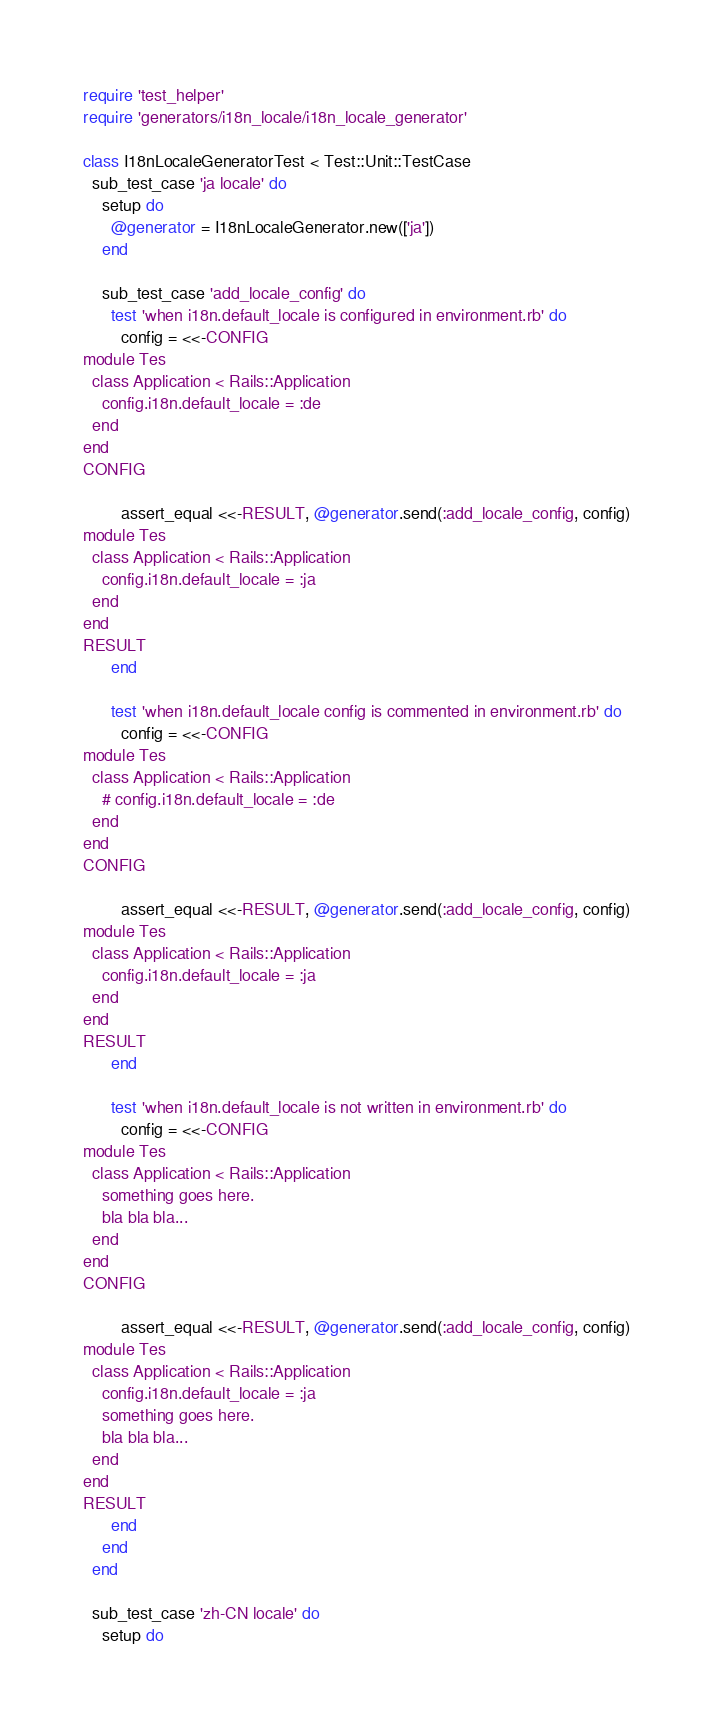Convert code to text. <code><loc_0><loc_0><loc_500><loc_500><_Ruby_>require 'test_helper'
require 'generators/i18n_locale/i18n_locale_generator'

class I18nLocaleGeneratorTest < Test::Unit::TestCase
  sub_test_case 'ja locale' do
    setup do
      @generator = I18nLocaleGenerator.new(['ja'])
    end

    sub_test_case 'add_locale_config' do
      test 'when i18n.default_locale is configured in environment.rb' do
        config = <<-CONFIG
module Tes
  class Application < Rails::Application
    config.i18n.default_locale = :de
  end
end
CONFIG

        assert_equal <<-RESULT, @generator.send(:add_locale_config, config)
module Tes
  class Application < Rails::Application
    config.i18n.default_locale = :ja
  end
end
RESULT
      end

      test 'when i18n.default_locale config is commented in environment.rb' do
        config = <<-CONFIG
module Tes
  class Application < Rails::Application
    # config.i18n.default_locale = :de
  end
end
CONFIG

        assert_equal <<-RESULT, @generator.send(:add_locale_config, config)
module Tes
  class Application < Rails::Application
    config.i18n.default_locale = :ja
  end
end
RESULT
      end

      test 'when i18n.default_locale is not written in environment.rb' do
        config = <<-CONFIG
module Tes
  class Application < Rails::Application
    something goes here.
    bla bla bla...
  end
end
CONFIG

        assert_equal <<-RESULT, @generator.send(:add_locale_config, config)
module Tes
  class Application < Rails::Application
    config.i18n.default_locale = :ja
    something goes here.
    bla bla bla...
  end
end
RESULT
      end
    end
  end

  sub_test_case 'zh-CN locale' do
    setup do</code> 